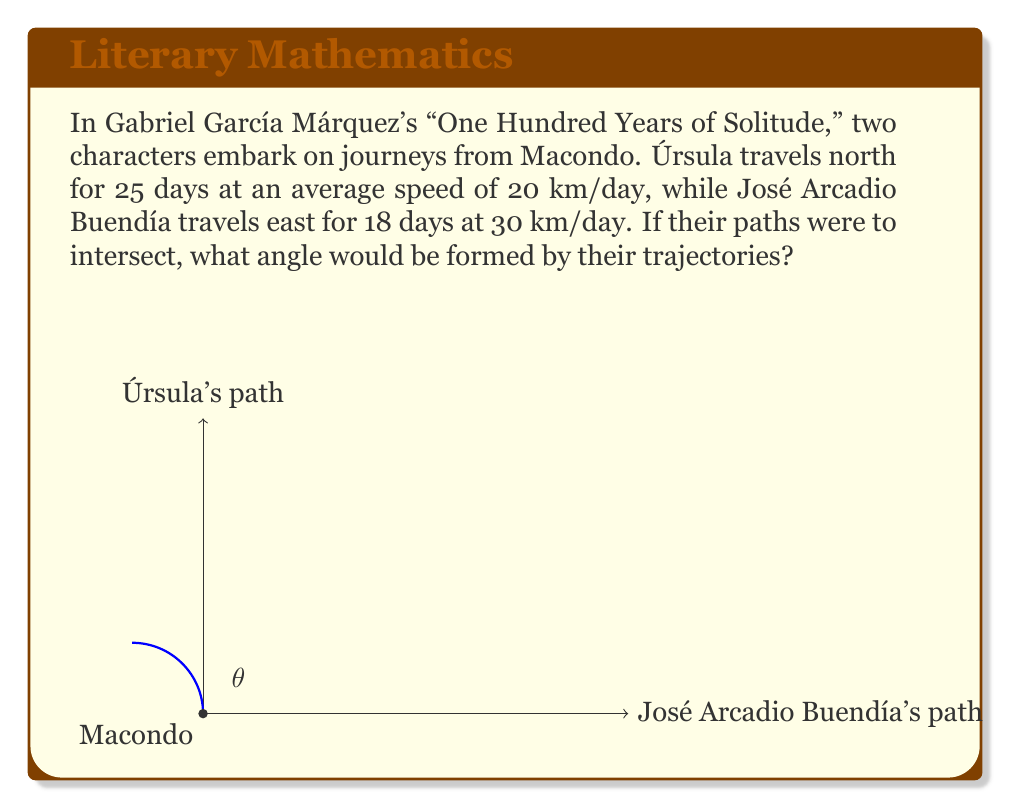Solve this math problem. To solve this problem, we'll use the arctangent function to find the angle formed by the two paths. Let's approach this step-by-step:

1) First, calculate the distances traveled by each character:
   Úrsula: $25 \text{ days} \times 20 \text{ km/day} = 500 \text{ km}$ (north)
   José Arcadio Buendía: $18 \text{ days} \times 30 \text{ km/day} = 540 \text{ km}$ (east)

2) These distances form the sides of a right-angled triangle, with Macondo at the right angle.

3) The angle we're looking for, let's call it $\theta$, is the one formed at Macondo between the northern path (Úrsula's) and the eastern path (José Arcadio Buendía's).

4) In this right-angled triangle:
   - The opposite side to $\theta$ is Úrsula's path (500 km)
   - The adjacent side to $\theta$ is José Arcadio Buendía's path (540 km)

5) We can find $\theta$ using the arctangent function:

   $$\theta = \arctan(\frac{\text{opposite}}{\text{adjacent}}) = \arctan(\frac{500}{540})$$

6) Calculate:
   $$\theta = \arctan(\frac{500}{540}) \approx 42.71^\circ$$

7) Round to the nearest degree:
   $$\theta \approx 43^\circ$$

Thus, the angle formed by the intersecting paths of Úrsula and José Arcadio Buendía would be approximately 43°.
Answer: $43^\circ$ 